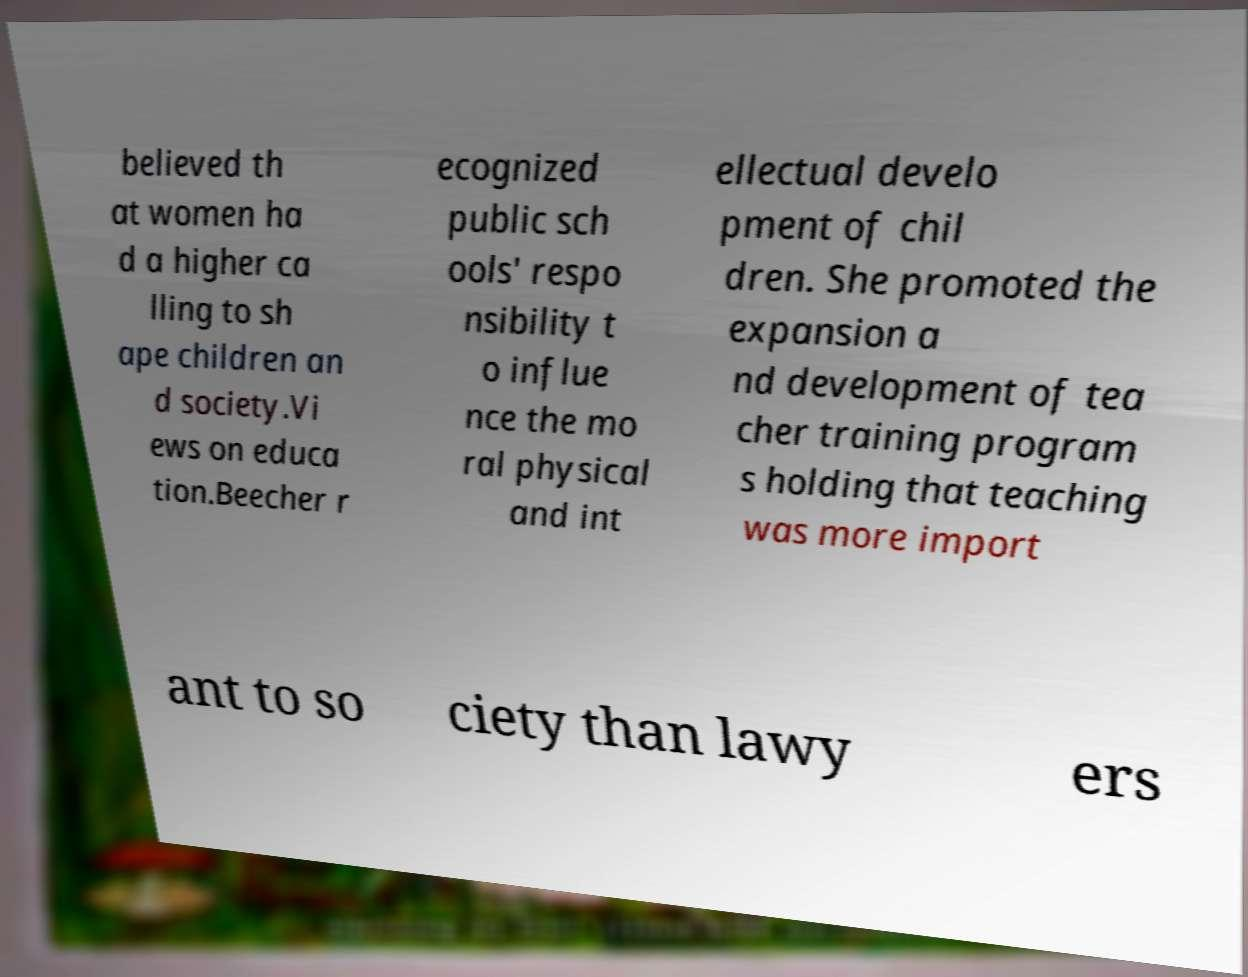Could you extract and type out the text from this image? believed th at women ha d a higher ca lling to sh ape children an d society.Vi ews on educa tion.Beecher r ecognized public sch ools' respo nsibility t o influe nce the mo ral physical and int ellectual develo pment of chil dren. She promoted the expansion a nd development of tea cher training program s holding that teaching was more import ant to so ciety than lawy ers 